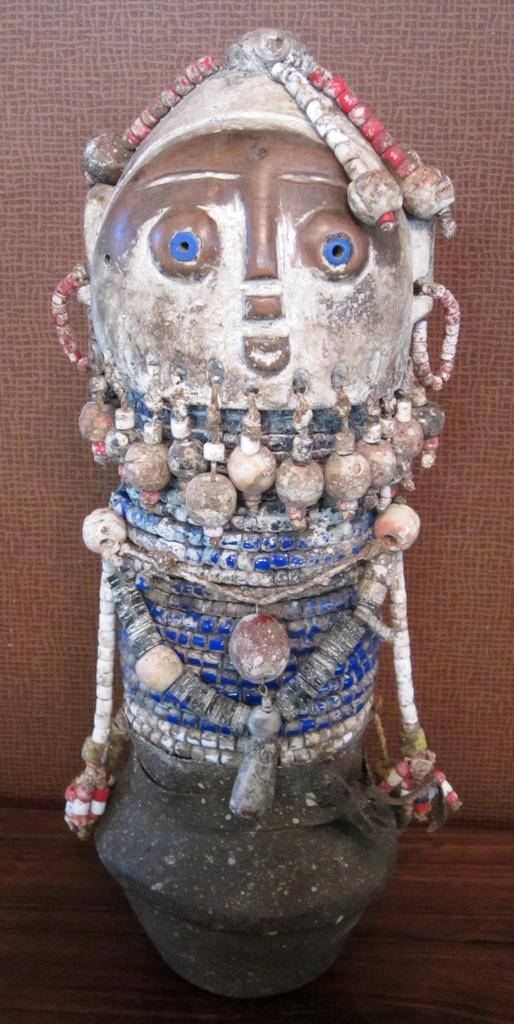What is the main subject in the image? There is a handicraft in the image. Can you describe the surface on which the handicraft is placed? The handicraft is on a wooden surface. What type of account does the handicraft have in the image? The handicraft does not have an account in the image, as it is an inanimate object and cannot have an account. 